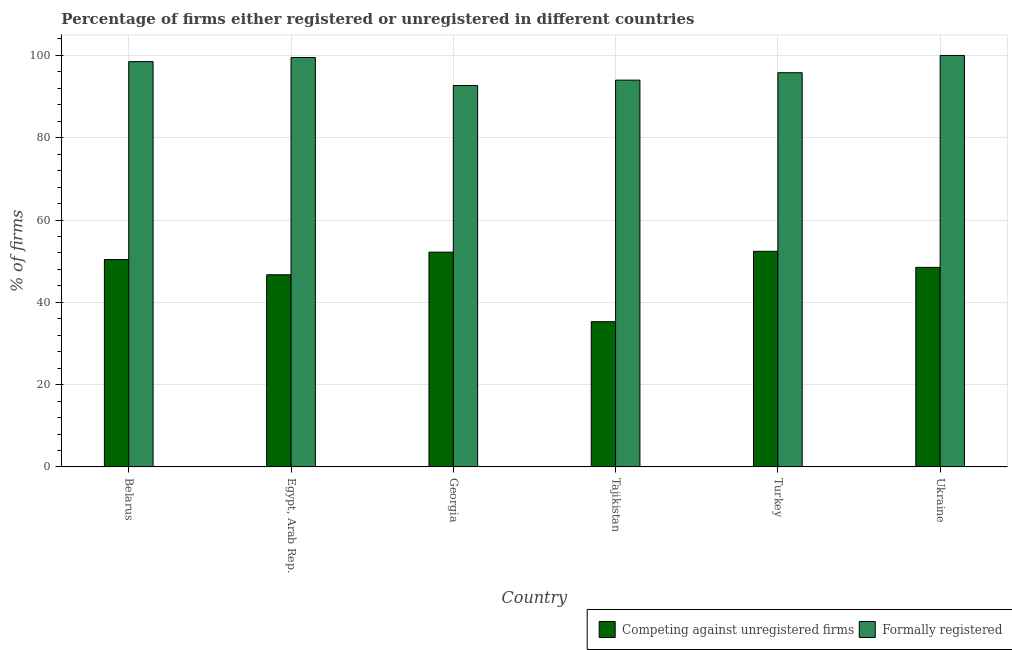How many groups of bars are there?
Your response must be concise. 6. Are the number of bars per tick equal to the number of legend labels?
Give a very brief answer. Yes. How many bars are there on the 3rd tick from the left?
Make the answer very short. 2. What is the label of the 5th group of bars from the left?
Your answer should be compact. Turkey. In how many cases, is the number of bars for a given country not equal to the number of legend labels?
Your answer should be compact. 0. What is the percentage of formally registered firms in Ukraine?
Ensure brevity in your answer.  100. Across all countries, what is the minimum percentage of formally registered firms?
Provide a short and direct response. 92.7. In which country was the percentage of formally registered firms maximum?
Ensure brevity in your answer.  Ukraine. In which country was the percentage of formally registered firms minimum?
Ensure brevity in your answer.  Georgia. What is the total percentage of formally registered firms in the graph?
Give a very brief answer. 580.5. What is the difference between the percentage of registered firms in Turkey and that in Ukraine?
Your answer should be compact. 3.9. What is the difference between the percentage of formally registered firms in Ukraine and the percentage of registered firms in Georgia?
Ensure brevity in your answer.  47.8. What is the average percentage of formally registered firms per country?
Offer a terse response. 96.75. What is the difference between the percentage of registered firms and percentage of formally registered firms in Ukraine?
Offer a terse response. -51.5. What is the ratio of the percentage of formally registered firms in Egypt, Arab Rep. to that in Tajikistan?
Make the answer very short. 1.06. Is the percentage of formally registered firms in Belarus less than that in Georgia?
Your answer should be very brief. No. Is the difference between the percentage of registered firms in Egypt, Arab Rep. and Turkey greater than the difference between the percentage of formally registered firms in Egypt, Arab Rep. and Turkey?
Your response must be concise. No. What is the difference between the highest and the second highest percentage of formally registered firms?
Provide a short and direct response. 0.5. What is the difference between the highest and the lowest percentage of formally registered firms?
Offer a very short reply. 7.3. In how many countries, is the percentage of formally registered firms greater than the average percentage of formally registered firms taken over all countries?
Your answer should be very brief. 3. Is the sum of the percentage of formally registered firms in Egypt, Arab Rep. and Tajikistan greater than the maximum percentage of registered firms across all countries?
Make the answer very short. Yes. What does the 2nd bar from the left in Georgia represents?
Your answer should be very brief. Formally registered. What does the 1st bar from the right in Belarus represents?
Provide a short and direct response. Formally registered. How many bars are there?
Your answer should be very brief. 12. How many countries are there in the graph?
Provide a short and direct response. 6. What is the difference between two consecutive major ticks on the Y-axis?
Offer a terse response. 20. Are the values on the major ticks of Y-axis written in scientific E-notation?
Your answer should be very brief. No. Does the graph contain any zero values?
Your answer should be compact. No. Does the graph contain grids?
Your answer should be very brief. Yes. How are the legend labels stacked?
Provide a short and direct response. Horizontal. What is the title of the graph?
Provide a succinct answer. Percentage of firms either registered or unregistered in different countries. What is the label or title of the X-axis?
Give a very brief answer. Country. What is the label or title of the Y-axis?
Offer a terse response. % of firms. What is the % of firms in Competing against unregistered firms in Belarus?
Provide a succinct answer. 50.4. What is the % of firms in Formally registered in Belarus?
Offer a terse response. 98.5. What is the % of firms in Competing against unregistered firms in Egypt, Arab Rep.?
Your answer should be compact. 46.7. What is the % of firms in Formally registered in Egypt, Arab Rep.?
Offer a terse response. 99.5. What is the % of firms in Competing against unregistered firms in Georgia?
Your answer should be very brief. 52.2. What is the % of firms in Formally registered in Georgia?
Make the answer very short. 92.7. What is the % of firms in Competing against unregistered firms in Tajikistan?
Your response must be concise. 35.3. What is the % of firms of Formally registered in Tajikistan?
Give a very brief answer. 94. What is the % of firms in Competing against unregistered firms in Turkey?
Your answer should be very brief. 52.4. What is the % of firms of Formally registered in Turkey?
Your response must be concise. 95.8. What is the % of firms of Competing against unregistered firms in Ukraine?
Your response must be concise. 48.5. What is the % of firms of Formally registered in Ukraine?
Your answer should be very brief. 100. Across all countries, what is the maximum % of firms in Competing against unregistered firms?
Provide a short and direct response. 52.4. Across all countries, what is the minimum % of firms in Competing against unregistered firms?
Offer a very short reply. 35.3. Across all countries, what is the minimum % of firms in Formally registered?
Provide a succinct answer. 92.7. What is the total % of firms of Competing against unregistered firms in the graph?
Ensure brevity in your answer.  285.5. What is the total % of firms of Formally registered in the graph?
Your response must be concise. 580.5. What is the difference between the % of firms of Formally registered in Belarus and that in Egypt, Arab Rep.?
Your answer should be very brief. -1. What is the difference between the % of firms of Competing against unregistered firms in Belarus and that in Georgia?
Offer a very short reply. -1.8. What is the difference between the % of firms of Formally registered in Belarus and that in Georgia?
Ensure brevity in your answer.  5.8. What is the difference between the % of firms of Competing against unregistered firms in Belarus and that in Ukraine?
Give a very brief answer. 1.9. What is the difference between the % of firms in Formally registered in Egypt, Arab Rep. and that in Georgia?
Keep it short and to the point. 6.8. What is the difference between the % of firms in Formally registered in Egypt, Arab Rep. and that in Ukraine?
Ensure brevity in your answer.  -0.5. What is the difference between the % of firms of Competing against unregistered firms in Georgia and that in Tajikistan?
Keep it short and to the point. 16.9. What is the difference between the % of firms of Formally registered in Georgia and that in Tajikistan?
Provide a short and direct response. -1.3. What is the difference between the % of firms of Competing against unregistered firms in Georgia and that in Turkey?
Offer a very short reply. -0.2. What is the difference between the % of firms of Formally registered in Georgia and that in Turkey?
Your answer should be very brief. -3.1. What is the difference between the % of firms in Formally registered in Georgia and that in Ukraine?
Offer a terse response. -7.3. What is the difference between the % of firms of Competing against unregistered firms in Tajikistan and that in Turkey?
Provide a succinct answer. -17.1. What is the difference between the % of firms in Competing against unregistered firms in Belarus and the % of firms in Formally registered in Egypt, Arab Rep.?
Provide a short and direct response. -49.1. What is the difference between the % of firms of Competing against unregistered firms in Belarus and the % of firms of Formally registered in Georgia?
Give a very brief answer. -42.3. What is the difference between the % of firms of Competing against unregistered firms in Belarus and the % of firms of Formally registered in Tajikistan?
Offer a terse response. -43.6. What is the difference between the % of firms of Competing against unregistered firms in Belarus and the % of firms of Formally registered in Turkey?
Offer a terse response. -45.4. What is the difference between the % of firms of Competing against unregistered firms in Belarus and the % of firms of Formally registered in Ukraine?
Make the answer very short. -49.6. What is the difference between the % of firms of Competing against unregistered firms in Egypt, Arab Rep. and the % of firms of Formally registered in Georgia?
Keep it short and to the point. -46. What is the difference between the % of firms in Competing against unregistered firms in Egypt, Arab Rep. and the % of firms in Formally registered in Tajikistan?
Your answer should be very brief. -47.3. What is the difference between the % of firms in Competing against unregistered firms in Egypt, Arab Rep. and the % of firms in Formally registered in Turkey?
Keep it short and to the point. -49.1. What is the difference between the % of firms of Competing against unregistered firms in Egypt, Arab Rep. and the % of firms of Formally registered in Ukraine?
Offer a very short reply. -53.3. What is the difference between the % of firms in Competing against unregistered firms in Georgia and the % of firms in Formally registered in Tajikistan?
Your response must be concise. -41.8. What is the difference between the % of firms in Competing against unregistered firms in Georgia and the % of firms in Formally registered in Turkey?
Make the answer very short. -43.6. What is the difference between the % of firms in Competing against unregistered firms in Georgia and the % of firms in Formally registered in Ukraine?
Your answer should be compact. -47.8. What is the difference between the % of firms of Competing against unregistered firms in Tajikistan and the % of firms of Formally registered in Turkey?
Your response must be concise. -60.5. What is the difference between the % of firms in Competing against unregistered firms in Tajikistan and the % of firms in Formally registered in Ukraine?
Provide a short and direct response. -64.7. What is the difference between the % of firms in Competing against unregistered firms in Turkey and the % of firms in Formally registered in Ukraine?
Provide a short and direct response. -47.6. What is the average % of firms in Competing against unregistered firms per country?
Provide a short and direct response. 47.58. What is the average % of firms in Formally registered per country?
Offer a very short reply. 96.75. What is the difference between the % of firms of Competing against unregistered firms and % of firms of Formally registered in Belarus?
Offer a terse response. -48.1. What is the difference between the % of firms of Competing against unregistered firms and % of firms of Formally registered in Egypt, Arab Rep.?
Offer a terse response. -52.8. What is the difference between the % of firms of Competing against unregistered firms and % of firms of Formally registered in Georgia?
Offer a very short reply. -40.5. What is the difference between the % of firms in Competing against unregistered firms and % of firms in Formally registered in Tajikistan?
Offer a very short reply. -58.7. What is the difference between the % of firms of Competing against unregistered firms and % of firms of Formally registered in Turkey?
Provide a succinct answer. -43.4. What is the difference between the % of firms in Competing against unregistered firms and % of firms in Formally registered in Ukraine?
Make the answer very short. -51.5. What is the ratio of the % of firms in Competing against unregistered firms in Belarus to that in Egypt, Arab Rep.?
Provide a succinct answer. 1.08. What is the ratio of the % of firms in Competing against unregistered firms in Belarus to that in Georgia?
Keep it short and to the point. 0.97. What is the ratio of the % of firms of Formally registered in Belarus to that in Georgia?
Offer a terse response. 1.06. What is the ratio of the % of firms in Competing against unregistered firms in Belarus to that in Tajikistan?
Provide a succinct answer. 1.43. What is the ratio of the % of firms of Formally registered in Belarus to that in Tajikistan?
Provide a short and direct response. 1.05. What is the ratio of the % of firms of Competing against unregistered firms in Belarus to that in Turkey?
Give a very brief answer. 0.96. What is the ratio of the % of firms in Formally registered in Belarus to that in Turkey?
Provide a succinct answer. 1.03. What is the ratio of the % of firms in Competing against unregistered firms in Belarus to that in Ukraine?
Offer a very short reply. 1.04. What is the ratio of the % of firms of Formally registered in Belarus to that in Ukraine?
Offer a very short reply. 0.98. What is the ratio of the % of firms in Competing against unregistered firms in Egypt, Arab Rep. to that in Georgia?
Offer a very short reply. 0.89. What is the ratio of the % of firms of Formally registered in Egypt, Arab Rep. to that in Georgia?
Provide a succinct answer. 1.07. What is the ratio of the % of firms of Competing against unregistered firms in Egypt, Arab Rep. to that in Tajikistan?
Your response must be concise. 1.32. What is the ratio of the % of firms of Formally registered in Egypt, Arab Rep. to that in Tajikistan?
Your answer should be compact. 1.06. What is the ratio of the % of firms of Competing against unregistered firms in Egypt, Arab Rep. to that in Turkey?
Keep it short and to the point. 0.89. What is the ratio of the % of firms of Formally registered in Egypt, Arab Rep. to that in Turkey?
Your answer should be compact. 1.04. What is the ratio of the % of firms of Competing against unregistered firms in Egypt, Arab Rep. to that in Ukraine?
Your answer should be compact. 0.96. What is the ratio of the % of firms of Formally registered in Egypt, Arab Rep. to that in Ukraine?
Your answer should be very brief. 0.99. What is the ratio of the % of firms in Competing against unregistered firms in Georgia to that in Tajikistan?
Offer a very short reply. 1.48. What is the ratio of the % of firms in Formally registered in Georgia to that in Tajikistan?
Provide a short and direct response. 0.99. What is the ratio of the % of firms in Competing against unregistered firms in Georgia to that in Turkey?
Offer a terse response. 1. What is the ratio of the % of firms in Formally registered in Georgia to that in Turkey?
Give a very brief answer. 0.97. What is the ratio of the % of firms of Competing against unregistered firms in Georgia to that in Ukraine?
Ensure brevity in your answer.  1.08. What is the ratio of the % of firms of Formally registered in Georgia to that in Ukraine?
Your answer should be very brief. 0.93. What is the ratio of the % of firms of Competing against unregistered firms in Tajikistan to that in Turkey?
Your response must be concise. 0.67. What is the ratio of the % of firms of Formally registered in Tajikistan to that in Turkey?
Ensure brevity in your answer.  0.98. What is the ratio of the % of firms in Competing against unregistered firms in Tajikistan to that in Ukraine?
Provide a succinct answer. 0.73. What is the ratio of the % of firms in Formally registered in Tajikistan to that in Ukraine?
Your response must be concise. 0.94. What is the ratio of the % of firms in Competing against unregistered firms in Turkey to that in Ukraine?
Provide a succinct answer. 1.08. What is the ratio of the % of firms of Formally registered in Turkey to that in Ukraine?
Provide a succinct answer. 0.96. What is the difference between the highest and the second highest % of firms in Formally registered?
Ensure brevity in your answer.  0.5. What is the difference between the highest and the lowest % of firms in Formally registered?
Your answer should be compact. 7.3. 